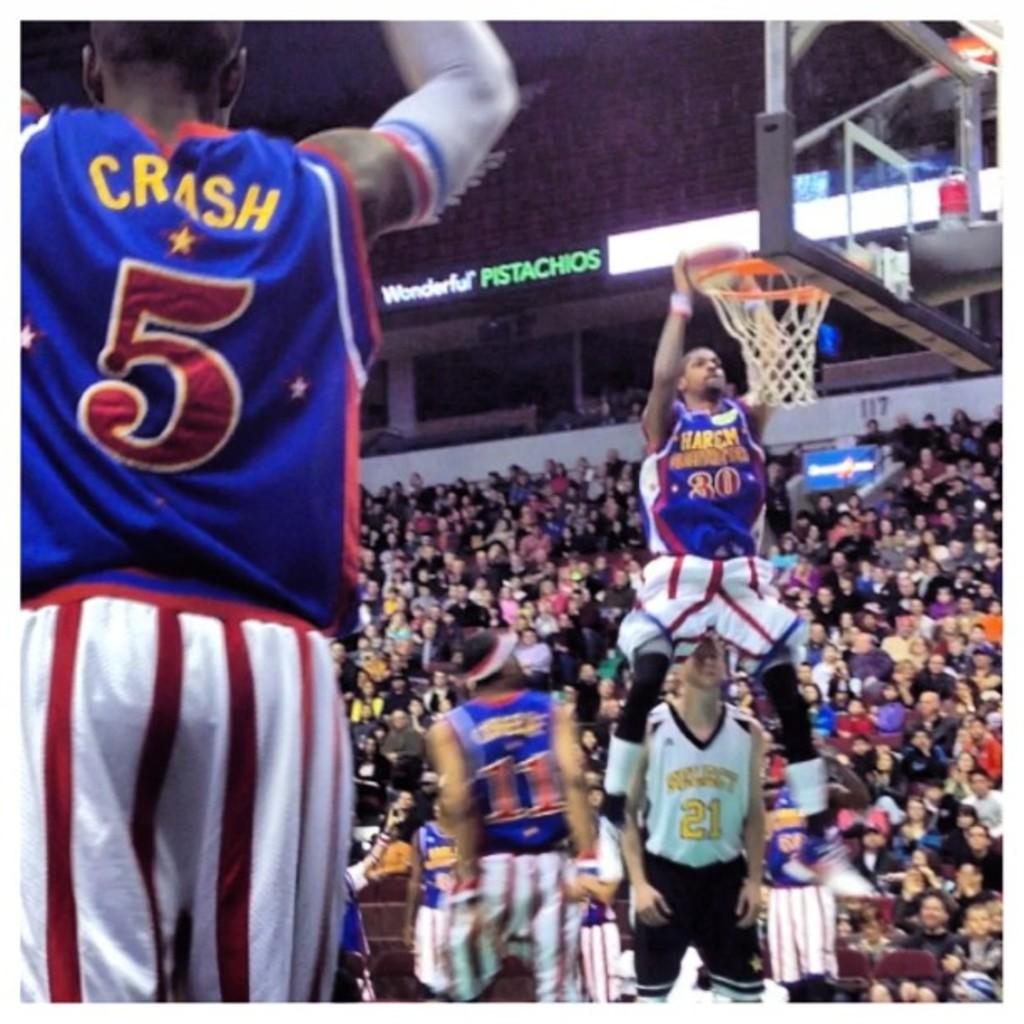What is the left player's name?
Keep it short and to the point. Crash. 